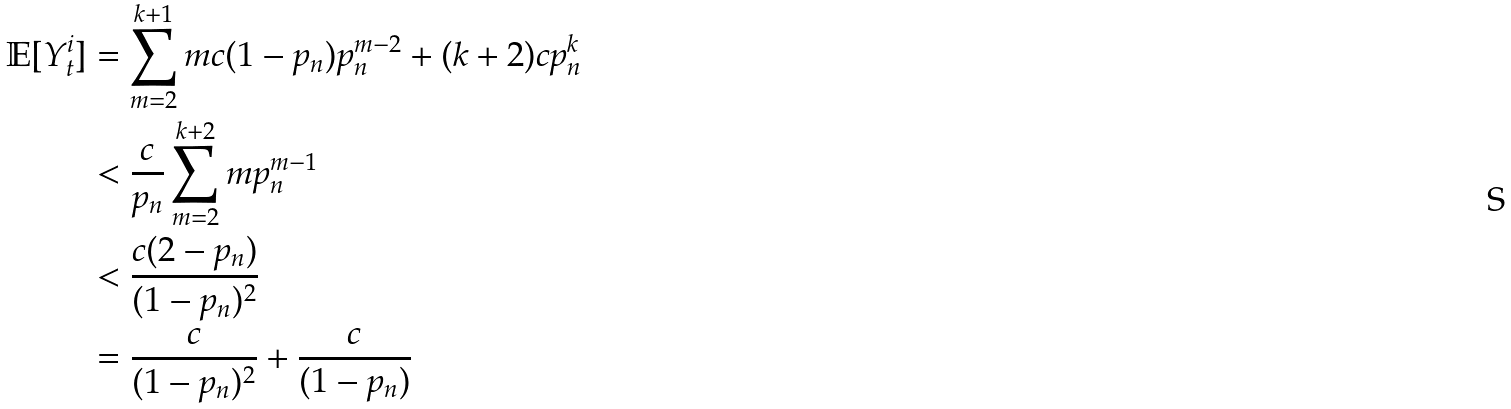<formula> <loc_0><loc_0><loc_500><loc_500>\mathbb { E } [ Y ^ { i } _ { t } ] & = \sum _ { m = 2 } ^ { k + 1 } m c ( 1 - p _ { n } ) p _ { n } ^ { m - 2 } + ( k + 2 ) c p _ { n } ^ { k } \\ & < \frac { c } { p _ { n } } \sum _ { m = 2 } ^ { k + 2 } m p _ { n } ^ { m - 1 } \\ & < \frac { c ( 2 - p _ { n } ) } { ( 1 - p _ { n } ) ^ { 2 } } \\ & = \frac { c } { ( 1 - p _ { n } ) ^ { 2 } } + \frac { c } { ( 1 - p _ { n } ) }</formula> 